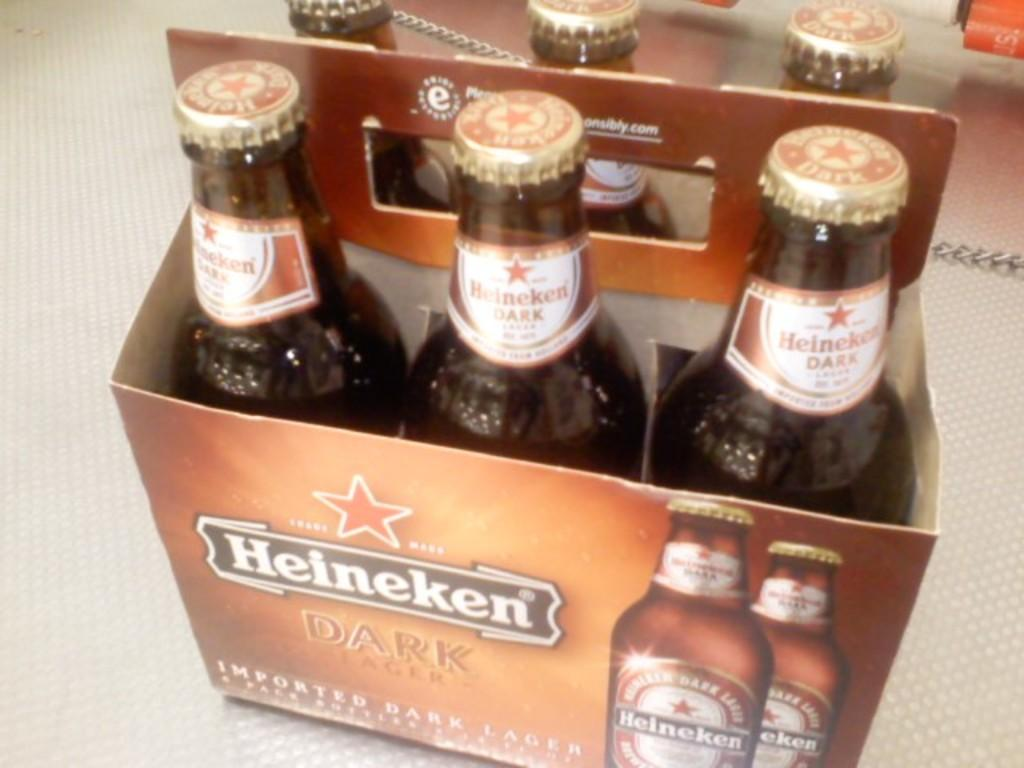<image>
Relay a brief, clear account of the picture shown. A six pack of bottled beer labeled Heineken Dark sitting on a white cloth. 